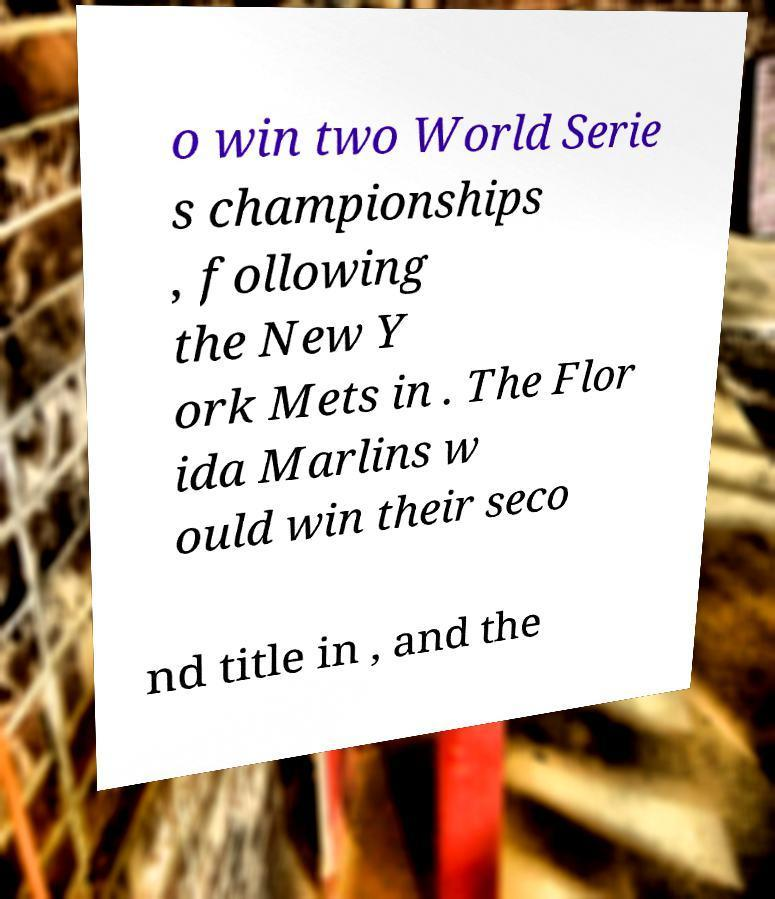Can you accurately transcribe the text from the provided image for me? o win two World Serie s championships , following the New Y ork Mets in . The Flor ida Marlins w ould win their seco nd title in , and the 